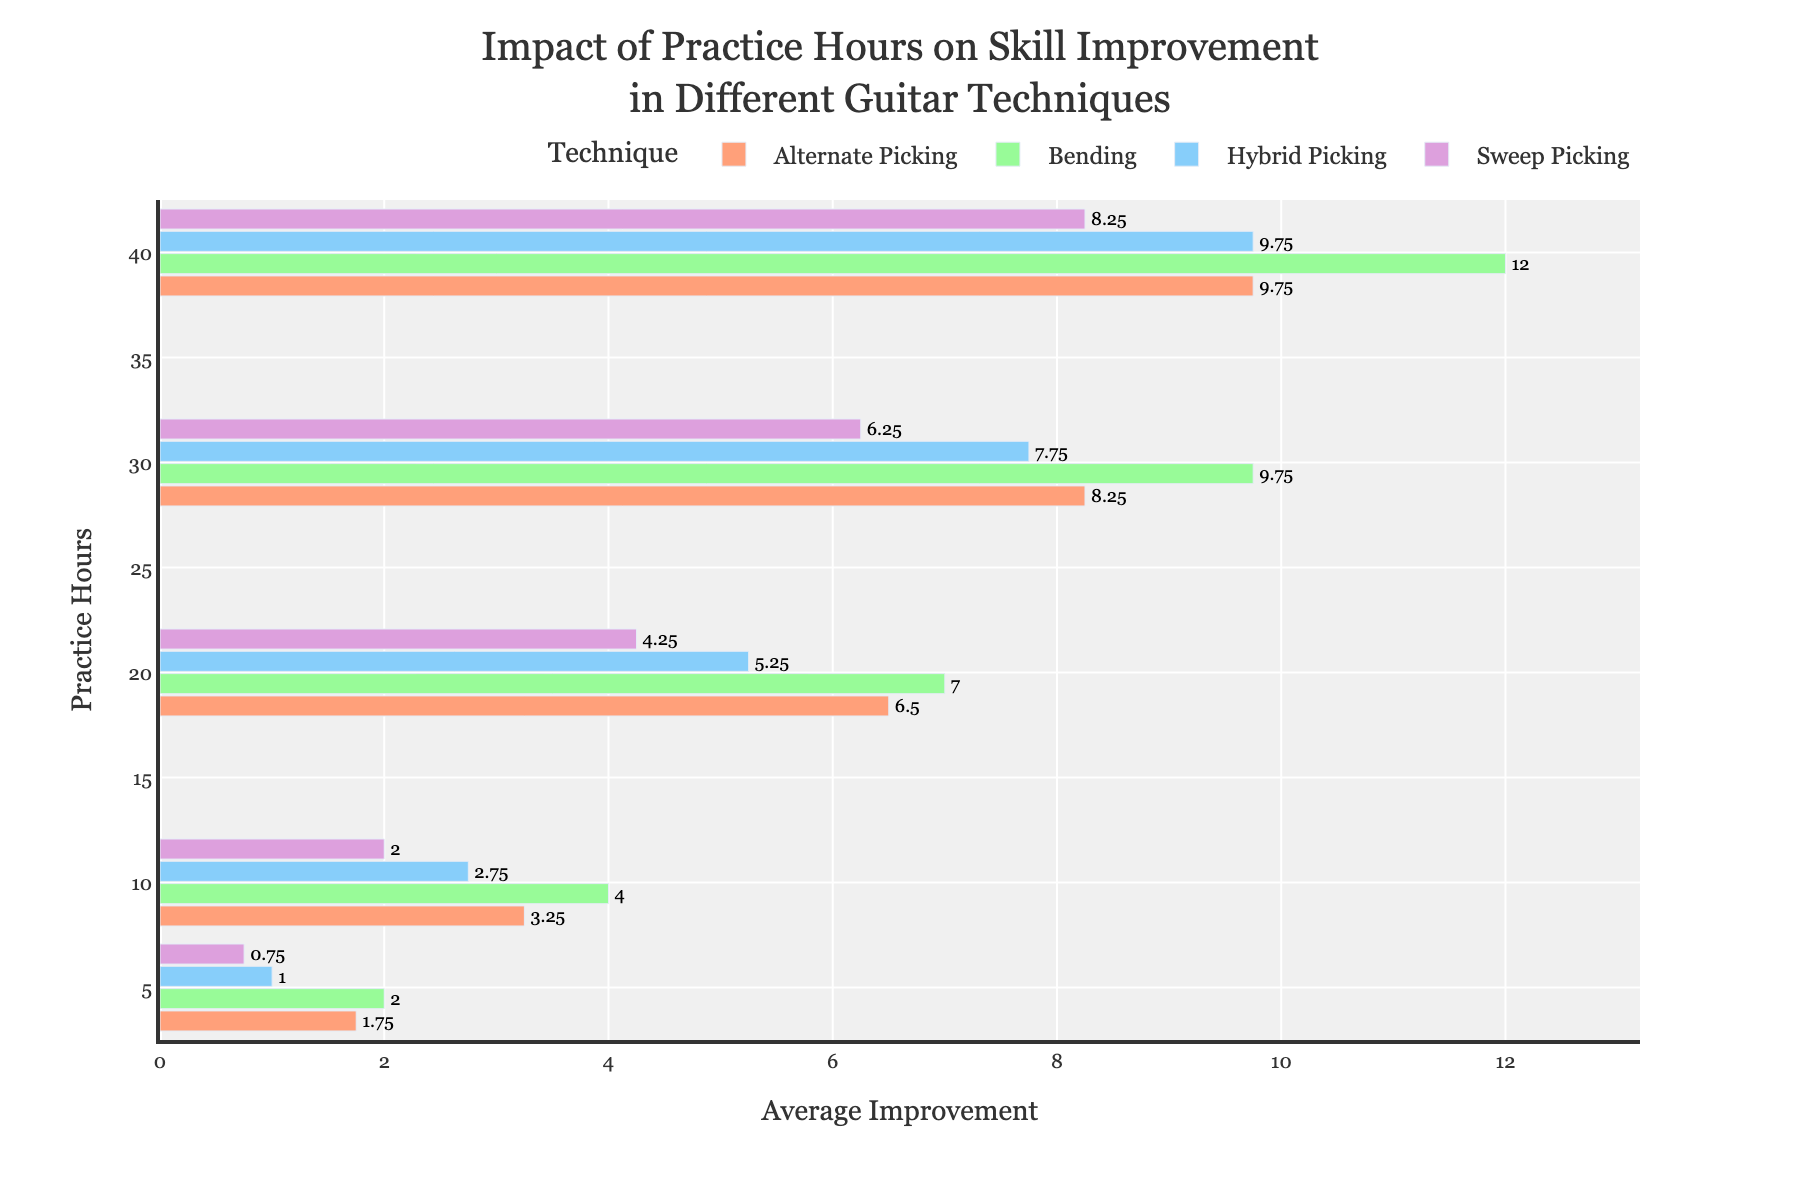Which technique shows the highest improvement with 20 hours of practice? Look at the Average Improvement for each technique with 20 hours of practice. Alternate Picking shows an improvement of 6.5, Bending shows 7, Hybrid Picking shows 5.25, and Sweep Picking shows 4.25.
Answer: Bending How does the improvement of Hybrid Picking with 30 hours of practice compare to that of Bending with 20 hours of practice? Look at the Average Improvement for Hybrid Picking with 30 hours, which is 7.75, and Bending with 20 hours, which is 7.
Answer: Hybrid Picking has a higher improvement What is the total average improvement across all techniques with 10 hours of practice? Sum the Average Improvement for each technique with 10 hours of practice: Alternate Picking (3.25) + Bending (4) + Hybrid Picking (2.75) + Sweep Picking (2). 3.25 + 4 + 2.75 + 2 = 12.
Answer: 12 Which technique demonstrates the least improvement with 5 hours of practice? Look at the Average Improvement for each technique with 5 hours of practice. Alternate Picking shows 1.75, Bending shows 2, Hybrid Picking shows 1, and Sweep Picking shows 0.75.
Answer: Sweep Picking On average, how much has Mike Stevens improved in Sweep Picking between 5 and 40 hours of practice? Extract and average Mike Stevens' improvements with 5, 10, 20, 30, and 40 hours: 0, 2, 5, 7, 9. Sum these values: 0 + 2 + 5 + 7 + 9 = 23. Divide by 5: 23 / 5.
Answer: 4.6 Between 30 and 40 hours of practice, which technique shows the greatest increase in average improvement? Calculate the difference in Average Improvement between 30 and 40 hours for each technique. Alternate Picking: 9.75 - 8.25 = 1.5, Bending: 12 - 9.75 = 2.25, Hybrid Picking: 9.75 - 7.75 = 2, Sweep Picking: 8.25 - 6.25 = 2.
Answer: Bending How does the improvement of Nancy Lane in Bending with 30 hours of practice compare to that of Tom Parker in Alternate Picking with the same practice duration? Nancy Lane shows an improvement of 8 in Bending, while Tom Parker shows an improvement of 8 in Alternate Picking with 30 hours of practice.
Answer: Equal What is the median value of improvement for Jenny Hawkins in all techniques with 10 hours of practice? List Jenny Hawkins' improvements with 10 hours across all techniques: Alternate Picking (2), Bending (4), Hybrid Picking (3), Sweep Picking (2). The median of [2, 4, 3, 2] is the average of the middle two numbers, 2 and 3.
Answer: 2.5 